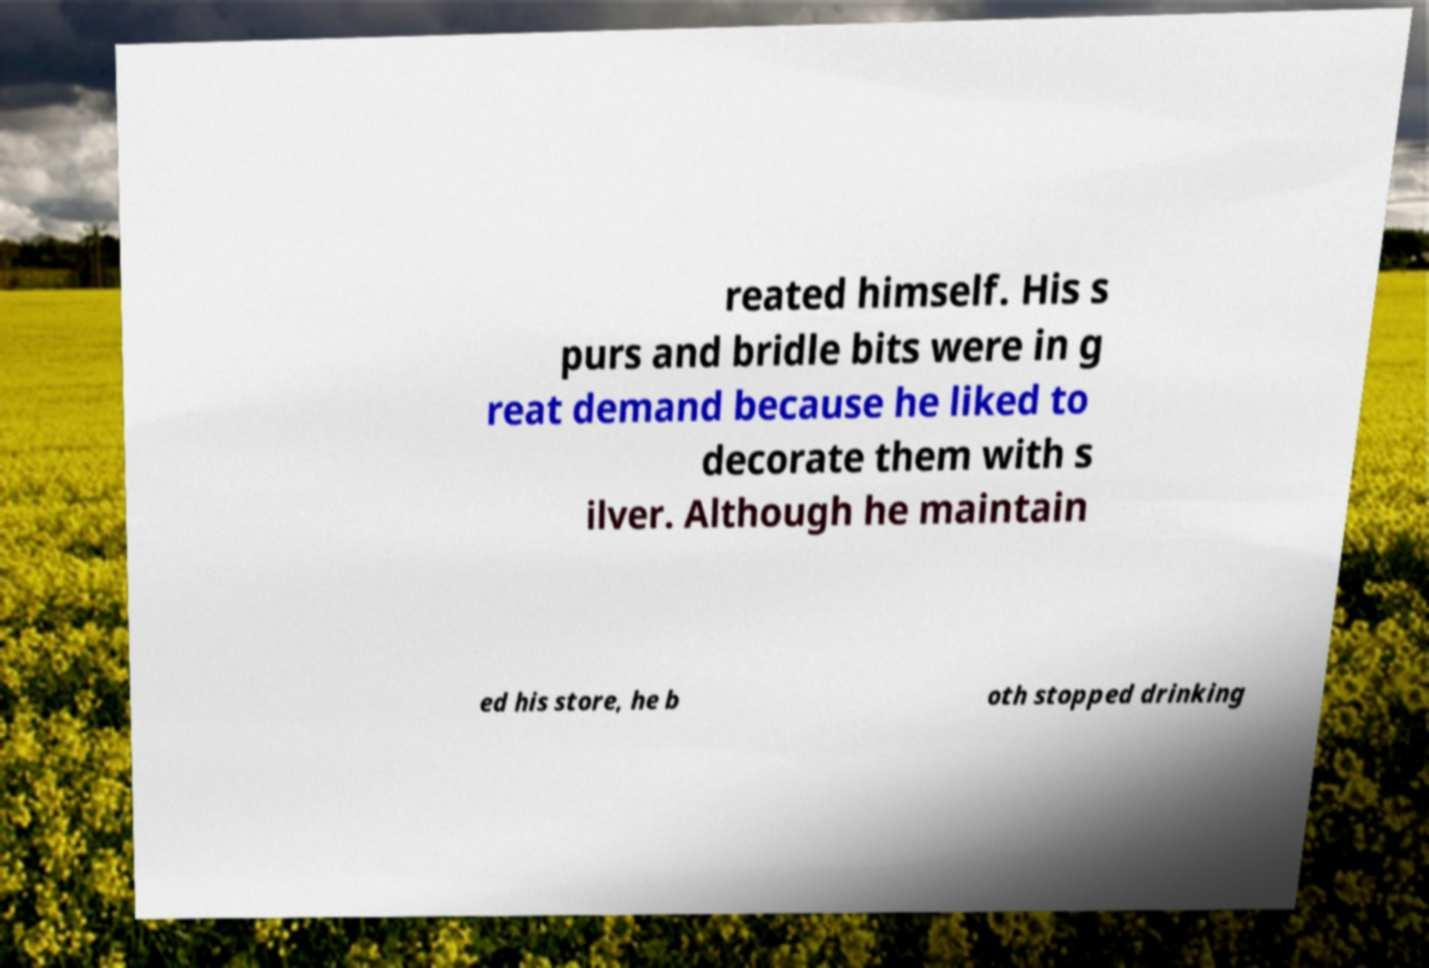Could you extract and type out the text from this image? reated himself. His s purs and bridle bits were in g reat demand because he liked to decorate them with s ilver. Although he maintain ed his store, he b oth stopped drinking 